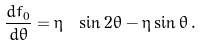<formula> <loc_0><loc_0><loc_500><loc_500>\frac { d f _ { 0 } } { d \theta } = \eta \ \sin 2 \theta - \eta \sin \theta \, .</formula> 